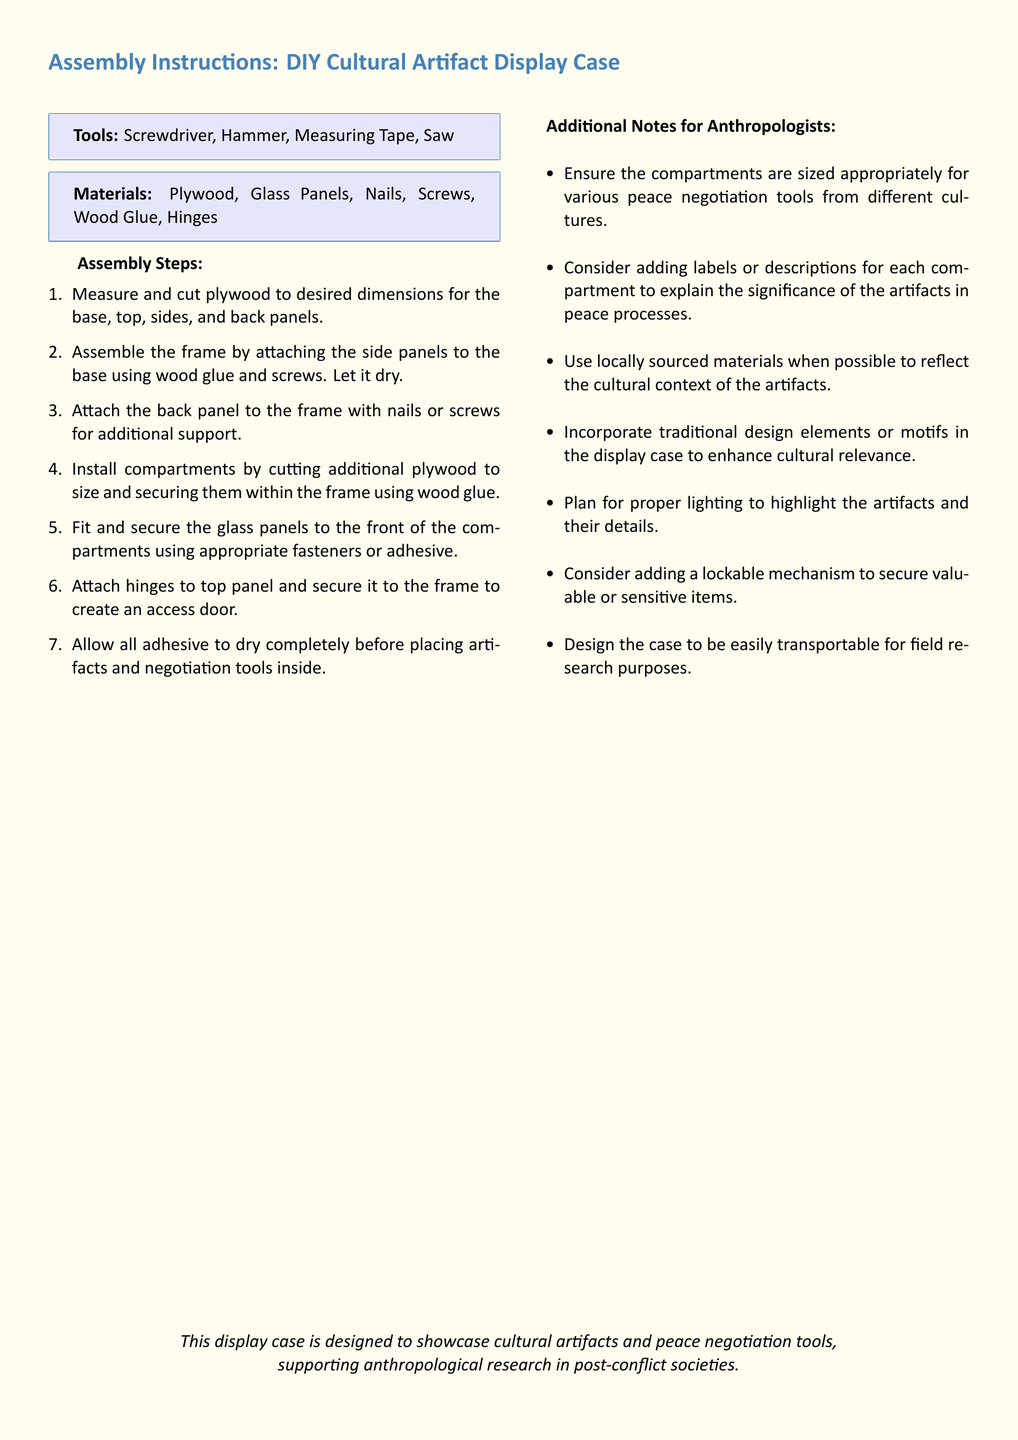What tools are needed for assembly? The document lists tools necessary for assembly.
Answer: Screwdriver, Hammer, Measuring Tape, Saw What is the first step in the assembly process? The first step outlined in the document for assembly.
Answer: Measure and cut plywood to desired dimensions How many types of materials are specified? The document categorizes materials into two main types.
Answer: 7 What should the compartments be sized for? The document specifies the purpose of the compartment sizes.
Answer: Various peace negotiation tools What is the purpose of the display case? The document states the overall intention behind creating the display case.
Answer: Showcase cultural artifacts and peace negotiation tools Which fastening method is suggested for securing the back panel? The document mentions a method for securing the back panel.
Answer: Nails or screws What additional feature is suggested for securing valuable items? The document provides a recommendation regarding security.
Answer: Lockable mechanism What is advised for displaying artifacts effectively? The document offers guidance on showcasing artifacts.
Answer: Proper lighting 